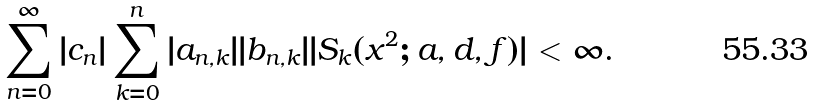<formula> <loc_0><loc_0><loc_500><loc_500>\sum _ { n = 0 } ^ { \infty } | c _ { n } | \sum _ { k = 0 } ^ { n } | a _ { n , k } | | b _ { n , k } | | S _ { k } ( x ^ { 2 } ; a , d , f ) | < \infty .</formula> 